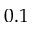<formula> <loc_0><loc_0><loc_500><loc_500>0 . 1</formula> 